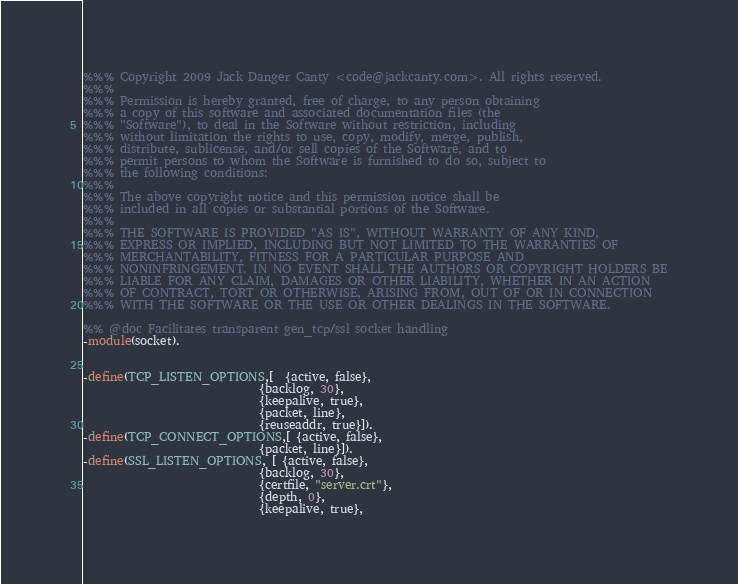<code> <loc_0><loc_0><loc_500><loc_500><_Erlang_>%%% Copyright 2009 Jack Danger Canty <code@jackcanty.com>. All rights reserved.
%%%
%%% Permission is hereby granted, free of charge, to any person obtaining
%%% a copy of this software and associated documentation files (the
%%% "Software"), to deal in the Software without restriction, including
%%% without limitation the rights to use, copy, modify, merge, publish,
%%% distribute, sublicense, and/or sell copies of the Software, and to
%%% permit persons to whom the Software is furnished to do so, subject to
%%% the following conditions:
%%%
%%% The above copyright notice and this permission notice shall be
%%% included in all copies or substantial portions of the Software.
%%%
%%% THE SOFTWARE IS PROVIDED "AS IS", WITHOUT WARRANTY OF ANY KIND,
%%% EXPRESS OR IMPLIED, INCLUDING BUT NOT LIMITED TO THE WARRANTIES OF
%%% MERCHANTABILITY, FITNESS FOR A PARTICULAR PURPOSE AND
%%% NONINFRINGEMENT. IN NO EVENT SHALL THE AUTHORS OR COPYRIGHT HOLDERS BE
%%% LIABLE FOR ANY CLAIM, DAMAGES OR OTHER LIABILITY, WHETHER IN AN ACTION
%%% OF CONTRACT, TORT OR OTHERWISE, ARISING FROM, OUT OF OR IN CONNECTION
%%% WITH THE SOFTWARE OR THE USE OR OTHER DEALINGS IN THE SOFTWARE.

%% @doc Facilitates transparent gen_tcp/ssl socket handling
-module(socket).


-define(TCP_LISTEN_OPTIONS,[  {active, false},
                              {backlog, 30},
                              {keepalive, true},
                              {packet, line},
                              {reuseaddr, true}]).
-define(TCP_CONNECT_OPTIONS,[ {active, false},
                              {packet, line}]).
-define(SSL_LISTEN_OPTIONS, [ {active, false},
                              {backlog, 30},
                              {certfile, "server.crt"},
                              {depth, 0},
                              {keepalive, true},</code> 